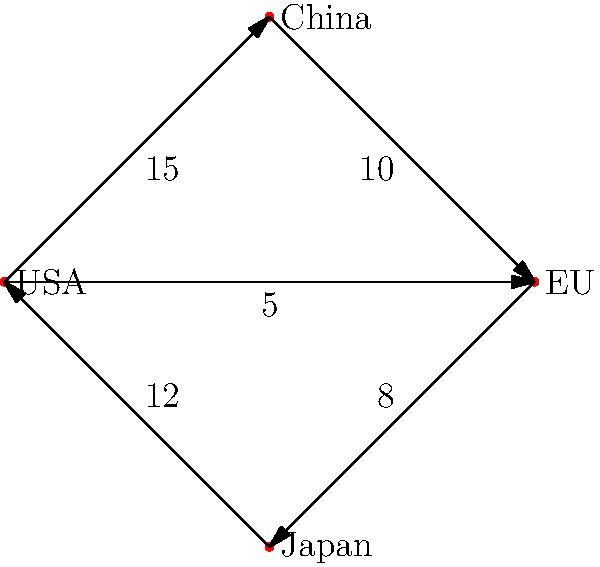In the given network flow diagram representing global seafood trade, what is the total export volume from the USA, and which country is its largest direct importer? To answer this question, we need to follow these steps:

1. Identify all outgoing flows from the USA node:
   - USA to China: 15 units
   - USA to EU: 5 units

2. Calculate the total export volume from the USA:
   $15 + 5 = 20$ units

3. Compare the export volumes to different countries:
   - To China: 15 units
   - To EU: 5 units

4. Identify the largest direct importer:
   China, with 15 units, is the largest direct importer from the USA.

Therefore, the total export volume from the USA is 20 units, and its largest direct importer is China.
Answer: 20 units; China 